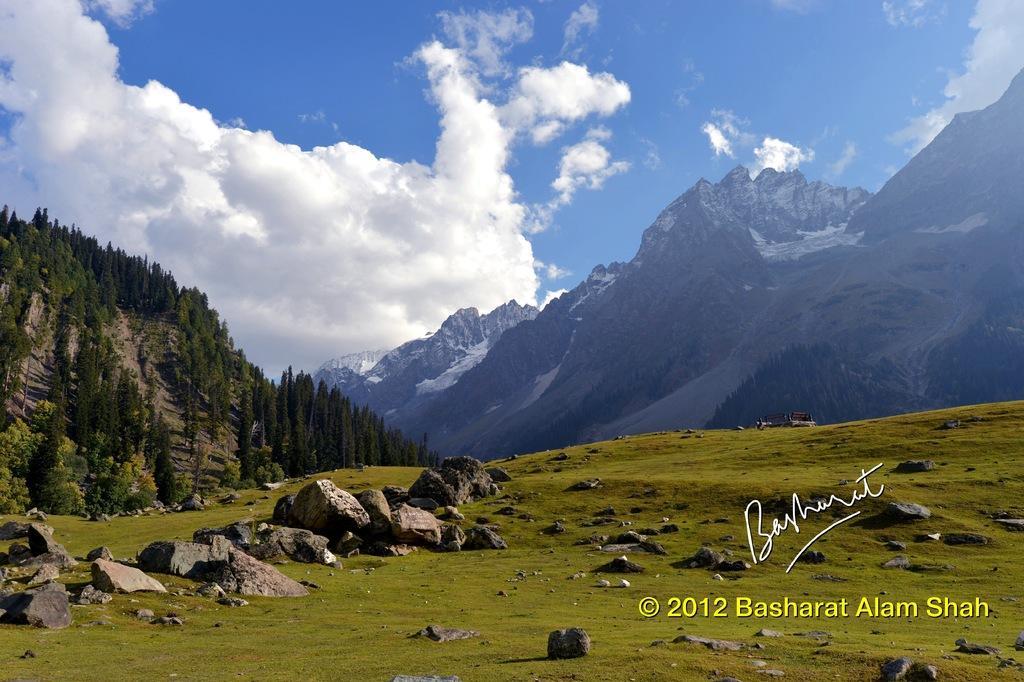Describe this image in one or two sentences. In this image there is the sky towards the top of the image, there are clouds in the sky, there are mountains, there are trees towards the left of the image, there is grass, there are rocks on the grass, there is text towards the bottom of the image, there is a number towards the bottom of the image, there is an object in the grass. 